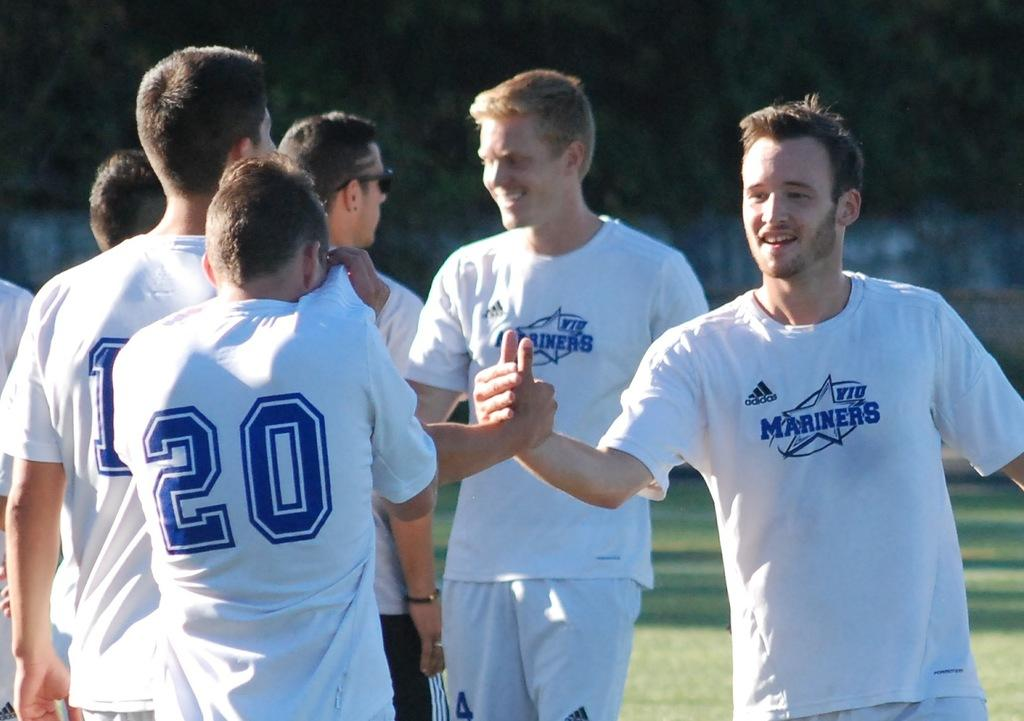<image>
Summarize the visual content of the image. The men of the Mariners are congratulating each other with handshakes 